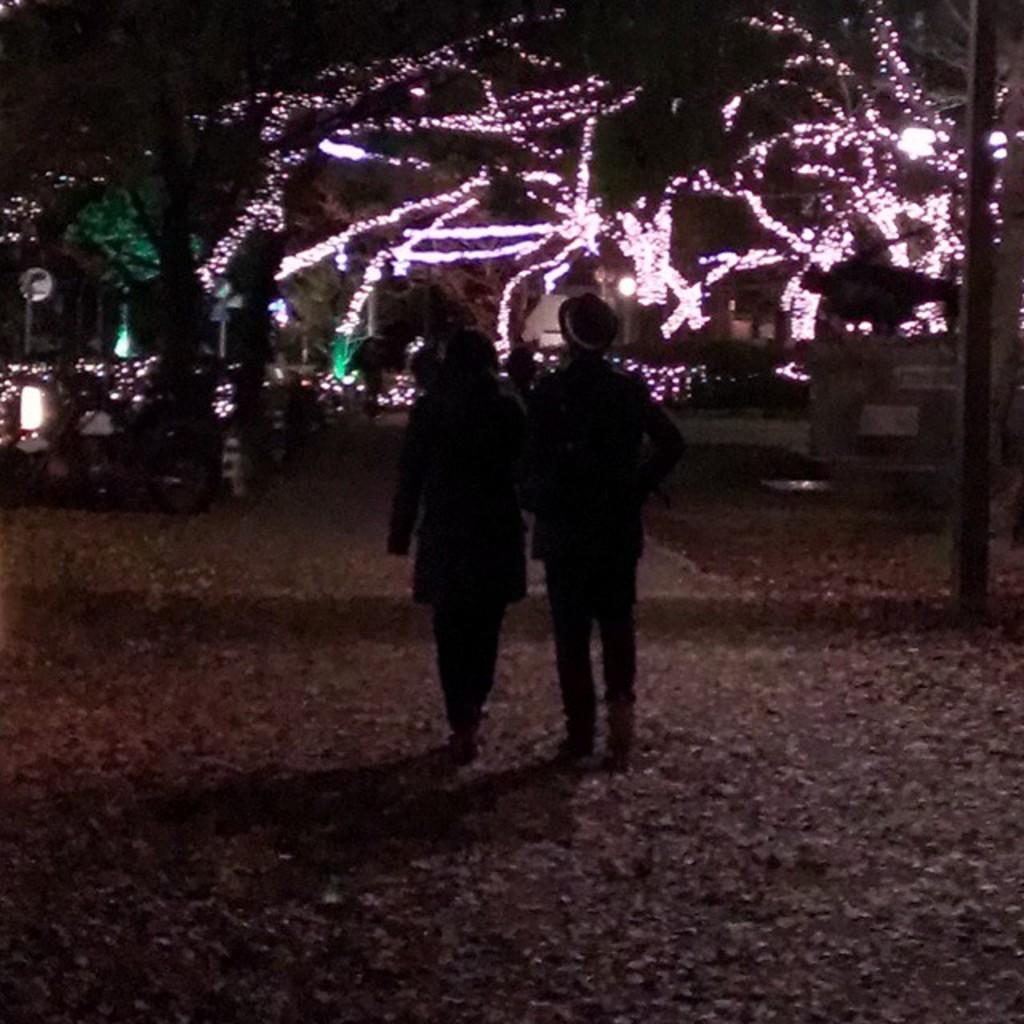Can you describe this image briefly? In front of the picture, we see two people are standing on the road. On the right side, we see a pole. In the background, we see trees and buildings. This road is decorated with lights. This picture is clicked in the dark. 